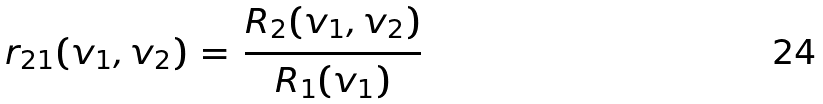<formula> <loc_0><loc_0><loc_500><loc_500>r _ { 2 1 } ( v _ { 1 } , v _ { 2 } ) \, = \, \frac { R _ { 2 } ( v _ { 1 } , v _ { 2 } ) } { R _ { 1 } ( v _ { 1 } ) }</formula> 